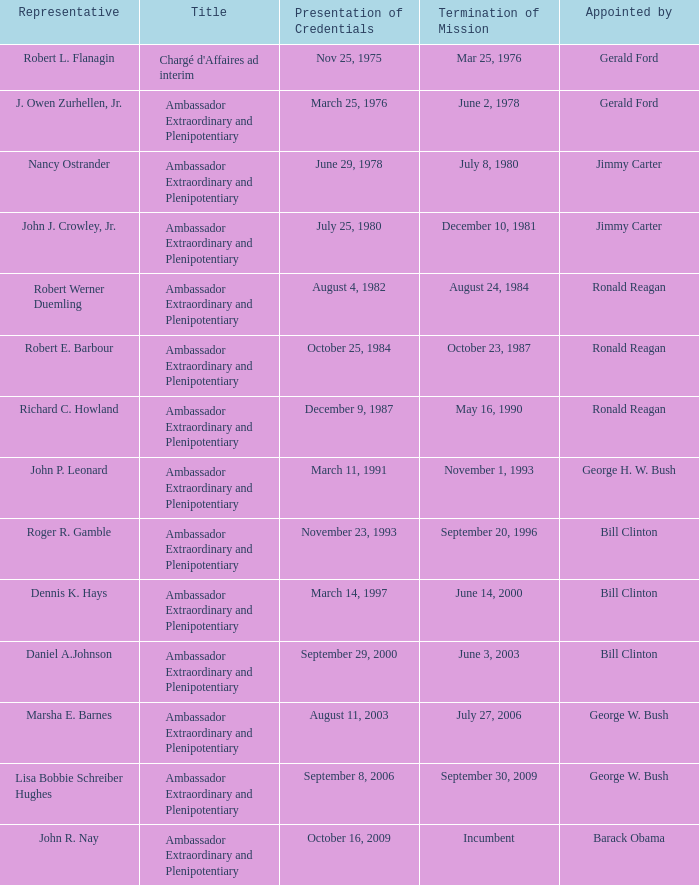Which representative has a Termination of MIssion date Mar 25, 1976? Robert L. Flanagin. 